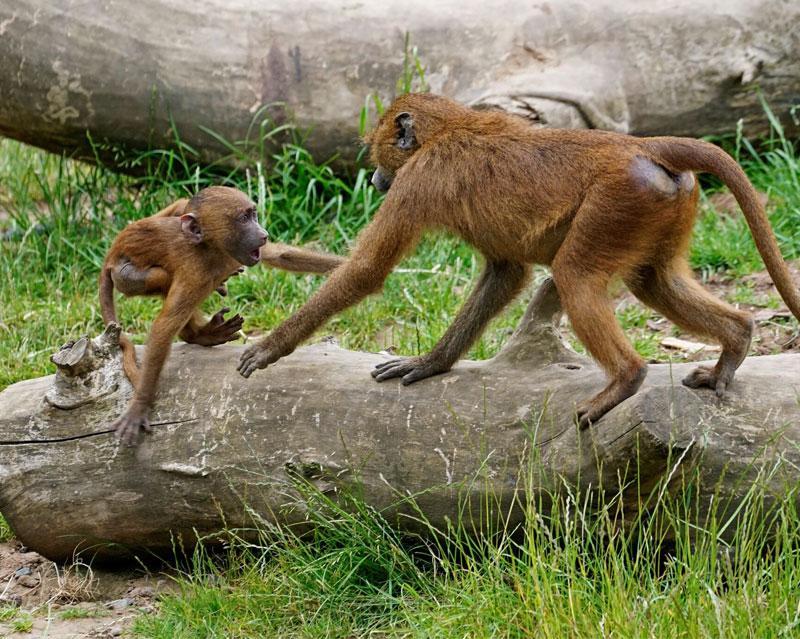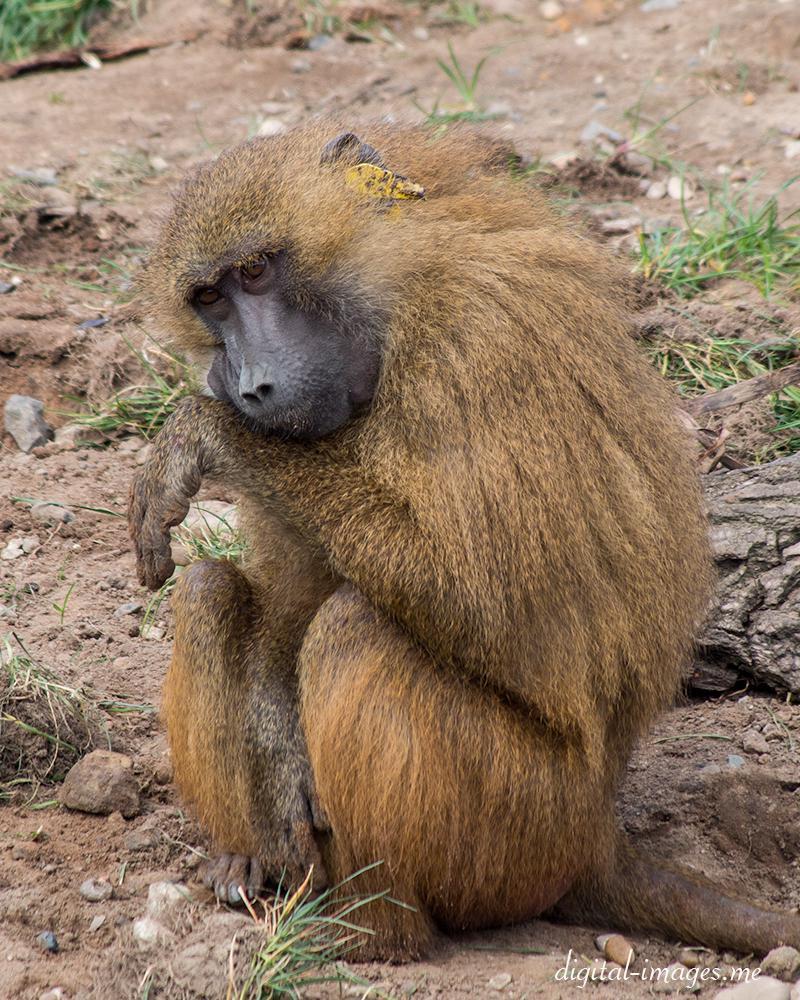The first image is the image on the left, the second image is the image on the right. Given the left and right images, does the statement "An image shows a baby baboon clinging, with its body pressed flat, to the back of an adult baboon walking on all fours." hold true? Answer yes or no. No. The first image is the image on the left, the second image is the image on the right. Evaluate the accuracy of this statement regarding the images: "The right image contains no more than one baboon.". Is it true? Answer yes or no. Yes. 